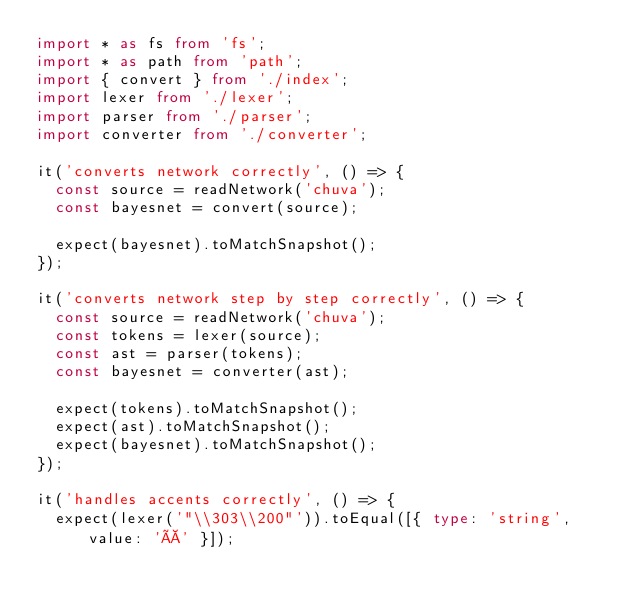<code> <loc_0><loc_0><loc_500><loc_500><_TypeScript_>import * as fs from 'fs';
import * as path from 'path';
import { convert } from './index';
import lexer from './lexer';
import parser from './parser';
import converter from './converter';

it('converts network correctly', () => {
  const source = readNetwork('chuva');
  const bayesnet = convert(source);

  expect(bayesnet).toMatchSnapshot();
});

it('converts network step by step correctly', () => {
  const source = readNetwork('chuva');
  const tokens = lexer(source);
  const ast = parser(tokens);
  const bayesnet = converter(ast);

  expect(tokens).toMatchSnapshot();
  expect(ast).toMatchSnapshot();
  expect(bayesnet).toMatchSnapshot();
});

it('handles accents correctly', () => {
  expect(lexer('"\\303\\200"')).toEqual([{ type: 'string', value: 'À' }]);</code> 